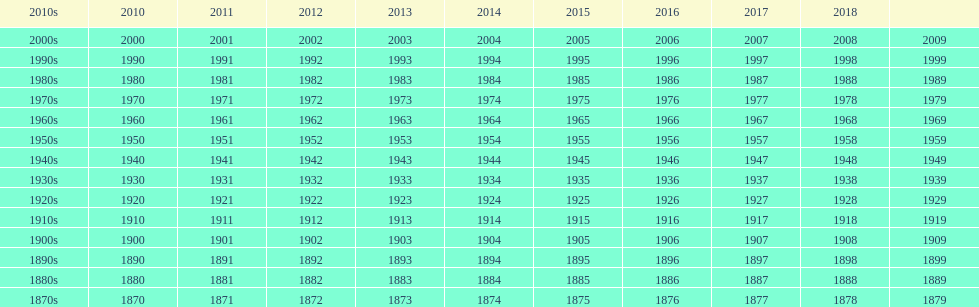What year is after 2018, but does not have a place on the table? 2019. 